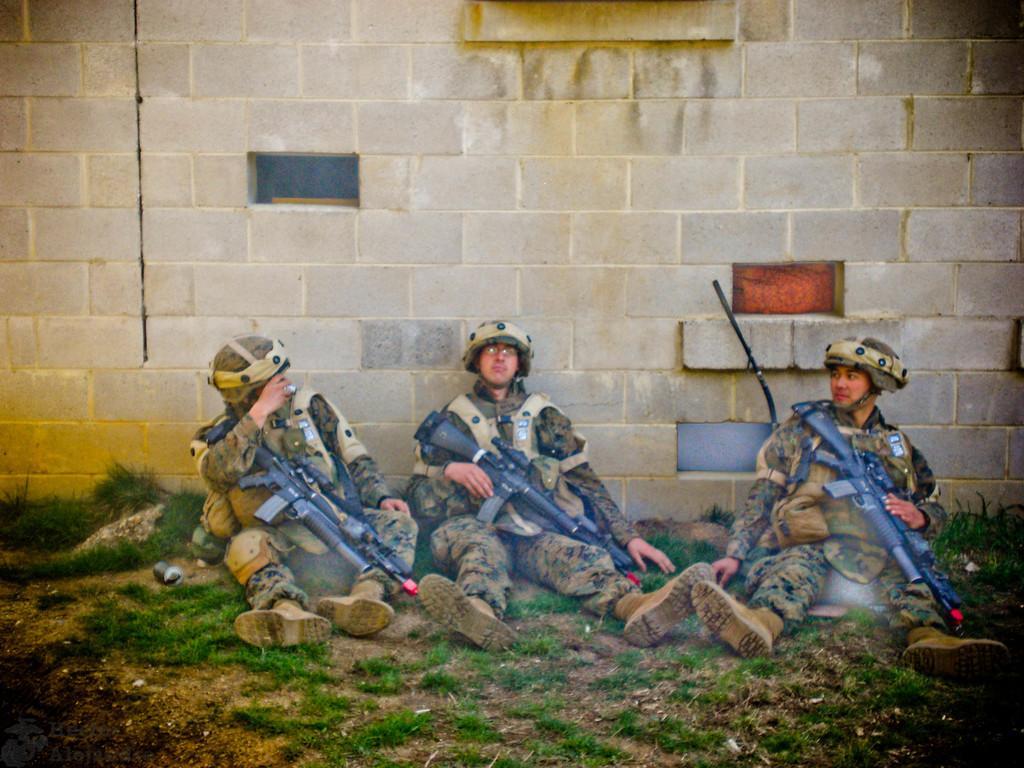In one or two sentences, can you explain what this image depicts? In this picture, we see three men in the uniform are sitting on the ground. Three of them are holding rifles in their hands. At the bottom of the picture, we see grass. Behind them, we see a wall. 